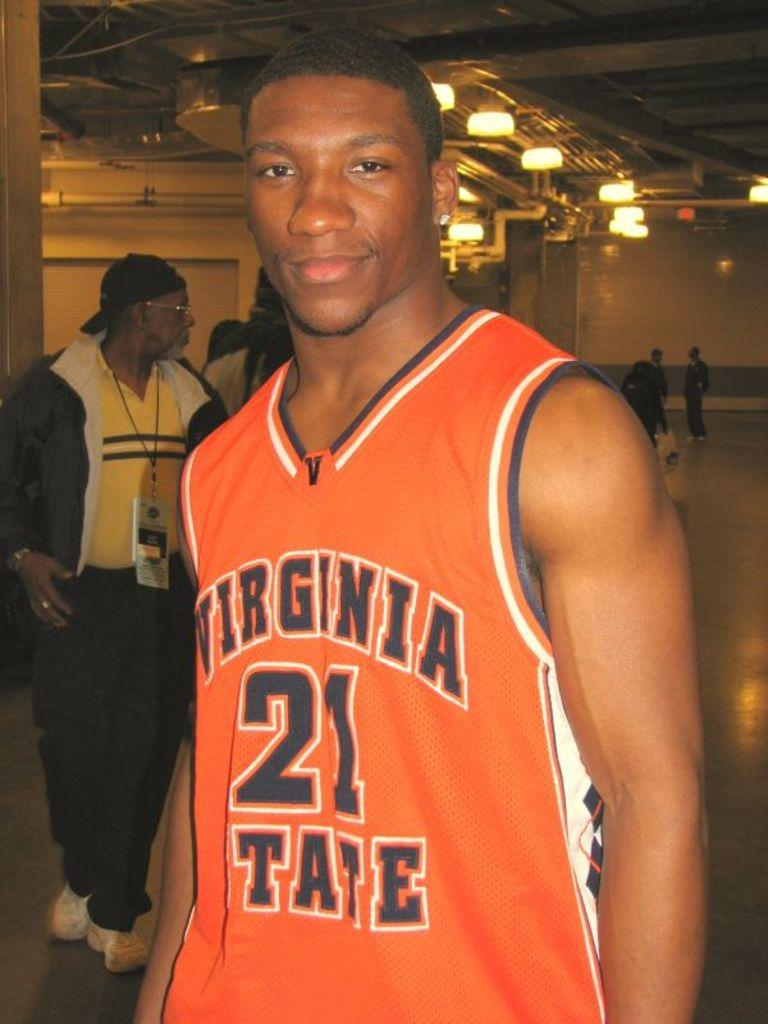<image>
Write a terse but informative summary of the picture. A basketball player for Virginia State wearing number 21 smiles for the camera. 